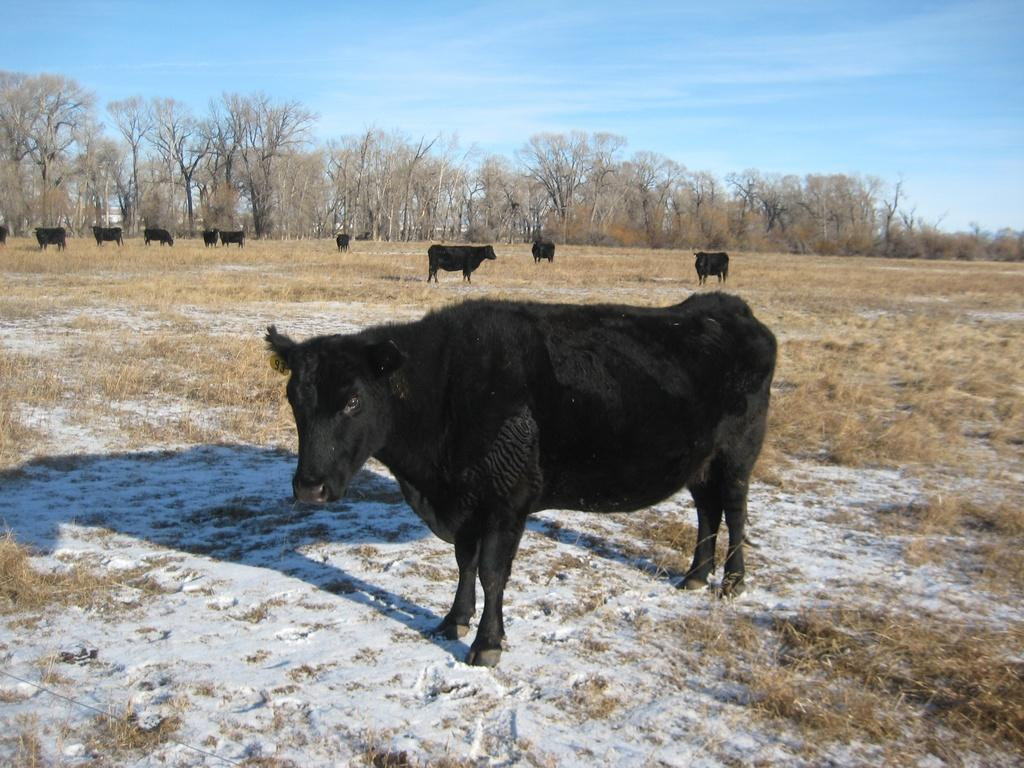What type of animals can be seen in the image? There are animals in the image, but their specific type is not mentioned in the facts. What is the ground covered with in the image? There is snow and grass in the image. What type of vegetation is present in the image? There are trees in the image. What can be seen in the background of the image? The sky is visible in the background of the image. What effect does the snow have on the development of the trees in the image? There is no information provided about the development of the trees or the effect of the snow on them in the image. 